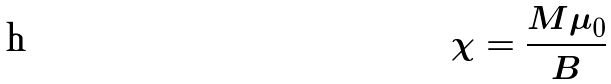<formula> <loc_0><loc_0><loc_500><loc_500>\chi = \frac { M \mu _ { 0 } } { B }</formula> 